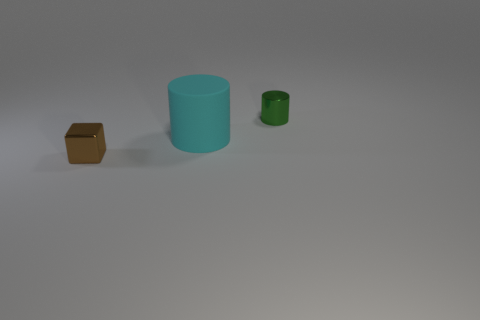Are there any other things that are the same size as the cyan matte cylinder?
Provide a succinct answer. No. What number of big cyan matte things are the same shape as the small brown thing?
Make the answer very short. 0. What is the color of the thing that is the same size as the cube?
Keep it short and to the point. Green. There is a metallic thing in front of the tiny shiny object behind the object in front of the large cylinder; what color is it?
Ensure brevity in your answer.  Brown. There is a brown metallic thing; does it have the same size as the metallic object to the right of the small brown shiny cube?
Offer a terse response. Yes. How many things are cubes or tiny blue spheres?
Your response must be concise. 1. Are there any brown spheres that have the same material as the cyan thing?
Your answer should be very brief. No. What is the color of the tiny object on the right side of the small metallic thing in front of the big thing?
Your answer should be compact. Green. Is the green thing the same size as the matte object?
Ensure brevity in your answer.  No. What number of cubes are either blue things or big cyan matte objects?
Your answer should be very brief. 0. 